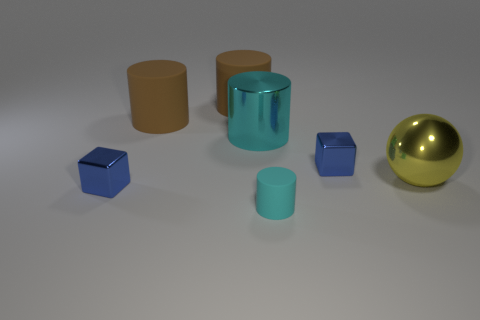Subtract all large cylinders. How many cylinders are left? 1 Subtract all brown spheres. How many brown cylinders are left? 2 Add 1 yellow balls. How many objects exist? 8 Subtract all cubes. How many objects are left? 5 Subtract all yellow cylinders. Subtract all red spheres. How many cylinders are left? 4 Add 6 large brown rubber things. How many large brown rubber things are left? 8 Add 6 large cylinders. How many large cylinders exist? 9 Subtract 0 green cubes. How many objects are left? 7 Subtract all small blue metallic objects. Subtract all metallic spheres. How many objects are left? 4 